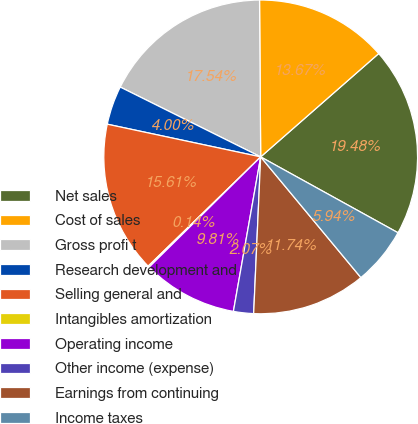Convert chart. <chart><loc_0><loc_0><loc_500><loc_500><pie_chart><fcel>Net sales<fcel>Cost of sales<fcel>Gross profi t<fcel>Research development and<fcel>Selling general and<fcel>Intangibles amortization<fcel>Operating income<fcel>Other income (expense)<fcel>Earnings from continuing<fcel>Income taxes<nl><fcel>19.48%<fcel>13.67%<fcel>17.54%<fcel>4.0%<fcel>15.61%<fcel>0.14%<fcel>9.81%<fcel>2.07%<fcel>11.74%<fcel>5.94%<nl></chart> 